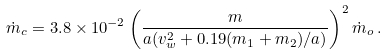Convert formula to latex. <formula><loc_0><loc_0><loc_500><loc_500>\dot { m } _ { c } = 3 . 8 \times 1 0 ^ { - 2 } \left ( \frac { m } { a ( v _ { w } ^ { 2 } + 0 . 1 9 ( m _ { 1 } + m _ { 2 } ) / a ) } \right ) ^ { 2 } \dot { m } _ { o } \, .</formula> 